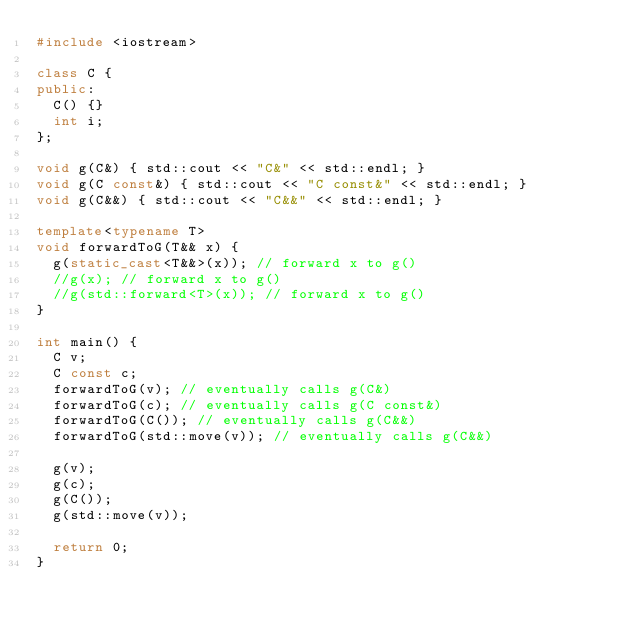Convert code to text. <code><loc_0><loc_0><loc_500><loc_500><_C++_>#include <iostream>

class C { 
public:
  C() {}
  int i;
};

void g(C&) { std::cout << "C&" << std::endl; }
void g(C const&) { std::cout << "C const&" << std::endl; }
void g(C&&) { std::cout << "C&&" << std::endl; }

template<typename T> 
void forwardToG(T&& x) {
  g(static_cast<T&&>(x)); // forward x to g()
  //g(x); // forward x to g()
  //g(std::forward<T>(x)); // forward x to g()
} 

int main() {
  C v;
  C const c;
  forwardToG(v); // eventually calls g(C&)
  forwardToG(c); // eventually calls g(C const&)
  forwardToG(C()); // eventually calls g(C&&)
  forwardToG(std::move(v)); // eventually calls g(C&&)

  g(v);
  g(c);
  g(C());
  g(std::move(v));

  return 0;
}

</code> 